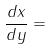Convert formula to latex. <formula><loc_0><loc_0><loc_500><loc_500>\frac { d x } { d y } =</formula> 